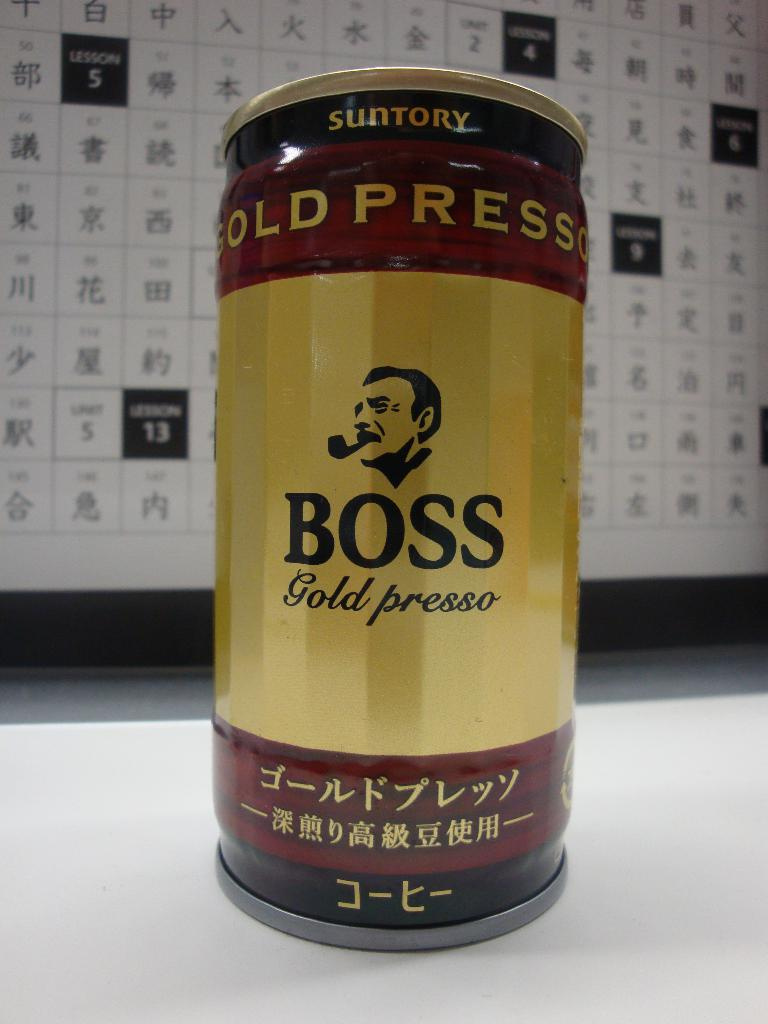Provide a one-sentence caption for the provided image. A vibrantly designed can of Suntory's BOSS Gold Presso coffee, featuring a striking logo of a man smoking a pipe in front of a backdrop filled with kanji characters, which give a cultural and traditional resonance to the presentation. 